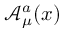Convert formula to latex. <formula><loc_0><loc_0><loc_500><loc_500>{ \mathcal { A } } _ { \mu } ^ { a } ( x )</formula> 